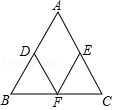Describe the process of constructing the midpoint of a line segment shown in this image. To construct the midpoint of a line segment, one would start by drawing the line segment, like AB in the image. Next, using a compass, one would draw arcs above and below the line from points A and B with the same radius—one that's more than half the length of the line segment. The intersection points of these arcs form a line perpendicular to the original line segment. The point where this new line intersects the original line segment is the midpoint, denoted as D in the image. This is a classic compass-and-straightedge construction in geometry. 